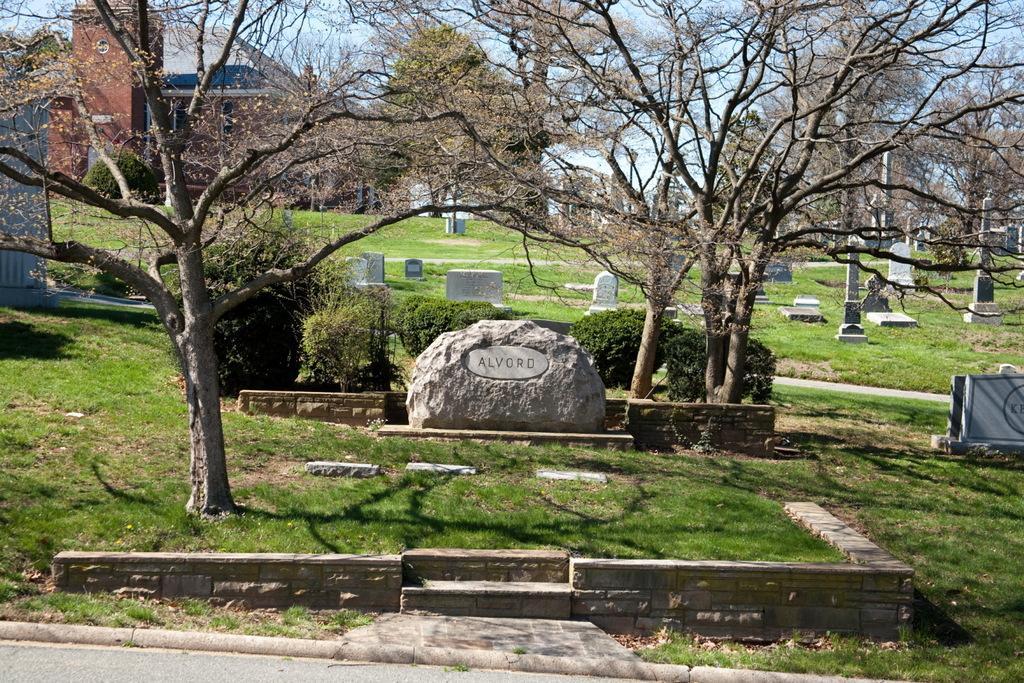Can you describe this image briefly? In this image I can see number of tombstones, plants, trees and grass. In the background I can see few buildings and the sky. I can also see shadows over here. 